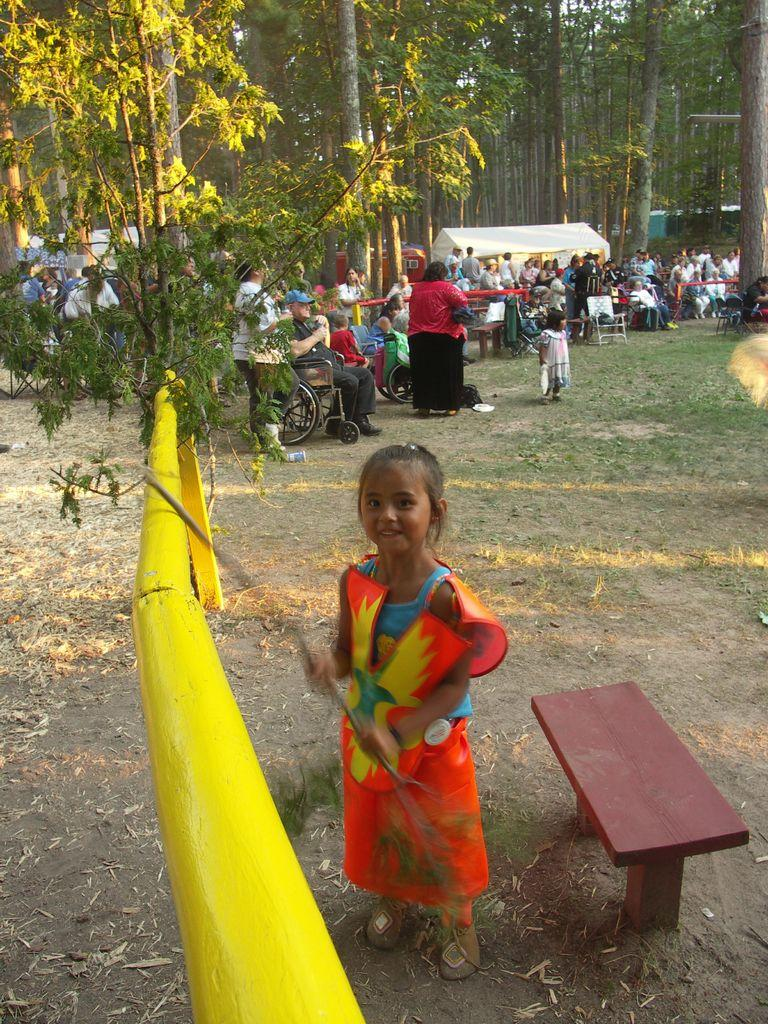Who is the main subject in the front of the image? There is a girl in the front of the image. What is the girl holding in her hand? The girl is holding a stick. What can be seen in the background of the image? There is a group of people standing and sitting in the background. What type of natural environment is visible in the image? Trees are visible in the image. What type of shelter is present in the image? There is a tent in the image. What type of whip is being used to cook food in the image? There is no whip or cooking activity present in the image. Where is the lock located on the tent in the image? There is no lock visible on the tent in the image. 